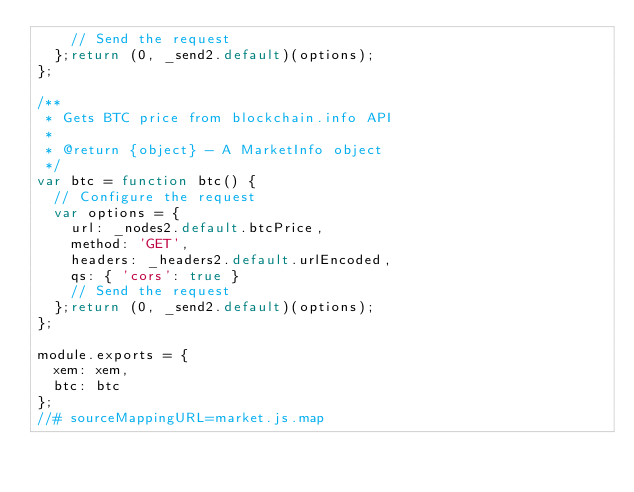<code> <loc_0><loc_0><loc_500><loc_500><_JavaScript_>		// Send the request
	};return (0, _send2.default)(options);
};

/**
 * Gets BTC price from blockchain.info API
 *
 * @return {object} - A MarketInfo object
 */
var btc = function btc() {
	// Configure the request
	var options = {
		url: _nodes2.default.btcPrice,
		method: 'GET',
		headers: _headers2.default.urlEncoded,
		qs: { 'cors': true }
		// Send the request
	};return (0, _send2.default)(options);
};

module.exports = {
	xem: xem,
	btc: btc
};
//# sourceMappingURL=market.js.map</code> 